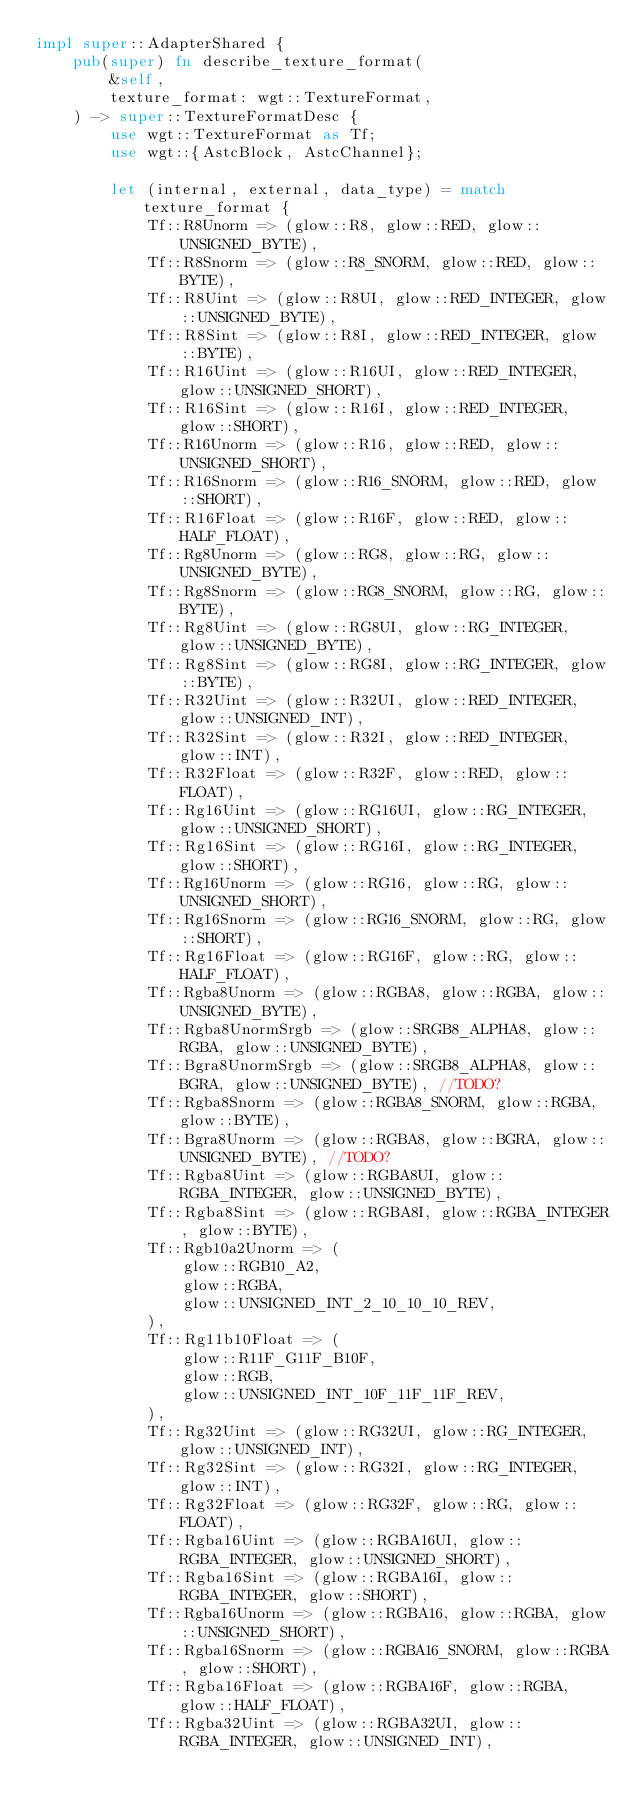<code> <loc_0><loc_0><loc_500><loc_500><_Rust_>impl super::AdapterShared {
    pub(super) fn describe_texture_format(
        &self,
        texture_format: wgt::TextureFormat,
    ) -> super::TextureFormatDesc {
        use wgt::TextureFormat as Tf;
        use wgt::{AstcBlock, AstcChannel};

        let (internal, external, data_type) = match texture_format {
            Tf::R8Unorm => (glow::R8, glow::RED, glow::UNSIGNED_BYTE),
            Tf::R8Snorm => (glow::R8_SNORM, glow::RED, glow::BYTE),
            Tf::R8Uint => (glow::R8UI, glow::RED_INTEGER, glow::UNSIGNED_BYTE),
            Tf::R8Sint => (glow::R8I, glow::RED_INTEGER, glow::BYTE),
            Tf::R16Uint => (glow::R16UI, glow::RED_INTEGER, glow::UNSIGNED_SHORT),
            Tf::R16Sint => (glow::R16I, glow::RED_INTEGER, glow::SHORT),
            Tf::R16Unorm => (glow::R16, glow::RED, glow::UNSIGNED_SHORT),
            Tf::R16Snorm => (glow::R16_SNORM, glow::RED, glow::SHORT),
            Tf::R16Float => (glow::R16F, glow::RED, glow::HALF_FLOAT),
            Tf::Rg8Unorm => (glow::RG8, glow::RG, glow::UNSIGNED_BYTE),
            Tf::Rg8Snorm => (glow::RG8_SNORM, glow::RG, glow::BYTE),
            Tf::Rg8Uint => (glow::RG8UI, glow::RG_INTEGER, glow::UNSIGNED_BYTE),
            Tf::Rg8Sint => (glow::RG8I, glow::RG_INTEGER, glow::BYTE),
            Tf::R32Uint => (glow::R32UI, glow::RED_INTEGER, glow::UNSIGNED_INT),
            Tf::R32Sint => (glow::R32I, glow::RED_INTEGER, glow::INT),
            Tf::R32Float => (glow::R32F, glow::RED, glow::FLOAT),
            Tf::Rg16Uint => (glow::RG16UI, glow::RG_INTEGER, glow::UNSIGNED_SHORT),
            Tf::Rg16Sint => (glow::RG16I, glow::RG_INTEGER, glow::SHORT),
            Tf::Rg16Unorm => (glow::RG16, glow::RG, glow::UNSIGNED_SHORT),
            Tf::Rg16Snorm => (glow::RG16_SNORM, glow::RG, glow::SHORT),
            Tf::Rg16Float => (glow::RG16F, glow::RG, glow::HALF_FLOAT),
            Tf::Rgba8Unorm => (glow::RGBA8, glow::RGBA, glow::UNSIGNED_BYTE),
            Tf::Rgba8UnormSrgb => (glow::SRGB8_ALPHA8, glow::RGBA, glow::UNSIGNED_BYTE),
            Tf::Bgra8UnormSrgb => (glow::SRGB8_ALPHA8, glow::BGRA, glow::UNSIGNED_BYTE), //TODO?
            Tf::Rgba8Snorm => (glow::RGBA8_SNORM, glow::RGBA, glow::BYTE),
            Tf::Bgra8Unorm => (glow::RGBA8, glow::BGRA, glow::UNSIGNED_BYTE), //TODO?
            Tf::Rgba8Uint => (glow::RGBA8UI, glow::RGBA_INTEGER, glow::UNSIGNED_BYTE),
            Tf::Rgba8Sint => (glow::RGBA8I, glow::RGBA_INTEGER, glow::BYTE),
            Tf::Rgb10a2Unorm => (
                glow::RGB10_A2,
                glow::RGBA,
                glow::UNSIGNED_INT_2_10_10_10_REV,
            ),
            Tf::Rg11b10Float => (
                glow::R11F_G11F_B10F,
                glow::RGB,
                glow::UNSIGNED_INT_10F_11F_11F_REV,
            ),
            Tf::Rg32Uint => (glow::RG32UI, glow::RG_INTEGER, glow::UNSIGNED_INT),
            Tf::Rg32Sint => (glow::RG32I, glow::RG_INTEGER, glow::INT),
            Tf::Rg32Float => (glow::RG32F, glow::RG, glow::FLOAT),
            Tf::Rgba16Uint => (glow::RGBA16UI, glow::RGBA_INTEGER, glow::UNSIGNED_SHORT),
            Tf::Rgba16Sint => (glow::RGBA16I, glow::RGBA_INTEGER, glow::SHORT),
            Tf::Rgba16Unorm => (glow::RGBA16, glow::RGBA, glow::UNSIGNED_SHORT),
            Tf::Rgba16Snorm => (glow::RGBA16_SNORM, glow::RGBA, glow::SHORT),
            Tf::Rgba16Float => (glow::RGBA16F, glow::RGBA, glow::HALF_FLOAT),
            Tf::Rgba32Uint => (glow::RGBA32UI, glow::RGBA_INTEGER, glow::UNSIGNED_INT),</code> 